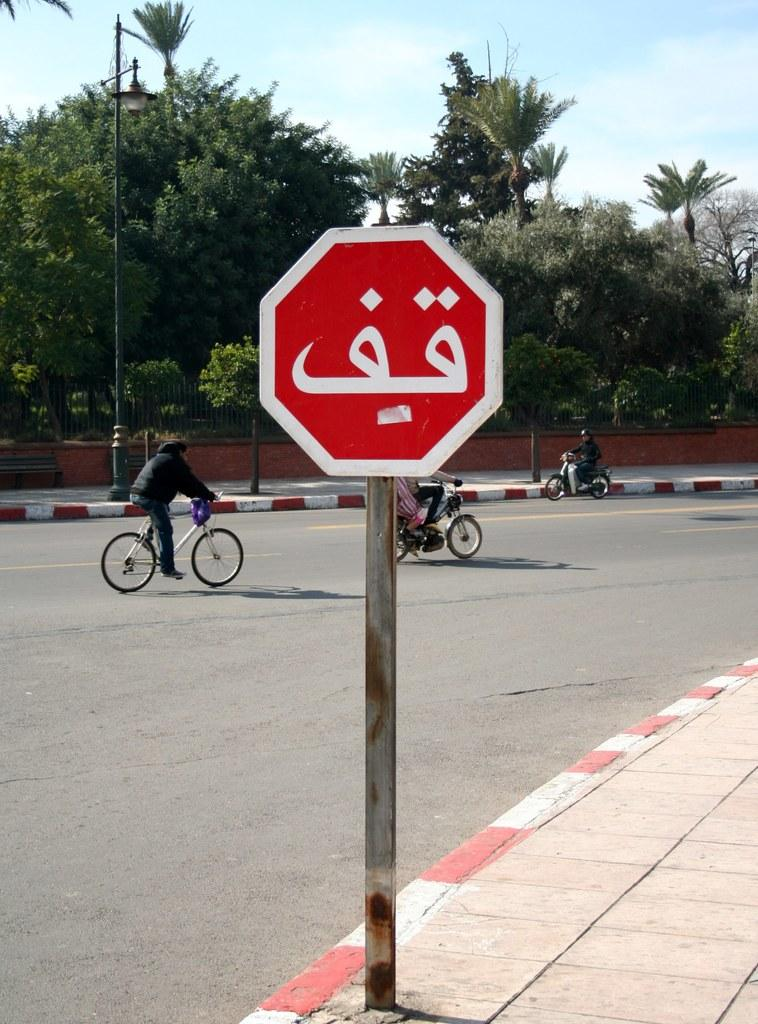What is the main object in the image? There is a board in the image. What other structures can be seen in the image? There are light poles in the image. What are the people in the image doing? Three persons are riding bikes on the road. What type of barrier is present in the image? There is a fence in the image. What type of vegetation is visible in the image? There are trees in the image. What part of the natural environment is visible in the image? The sky is visible in the image. Can you determine the time of day the image was taken? The image appears to be taken during the day. What type of glue is being used to hold the calendar in the image? There is no calendar or glue present in the image. How does the steam affect the visibility of the road in the image? There is no steam present in the image, so it does not affect the visibility of the road. 